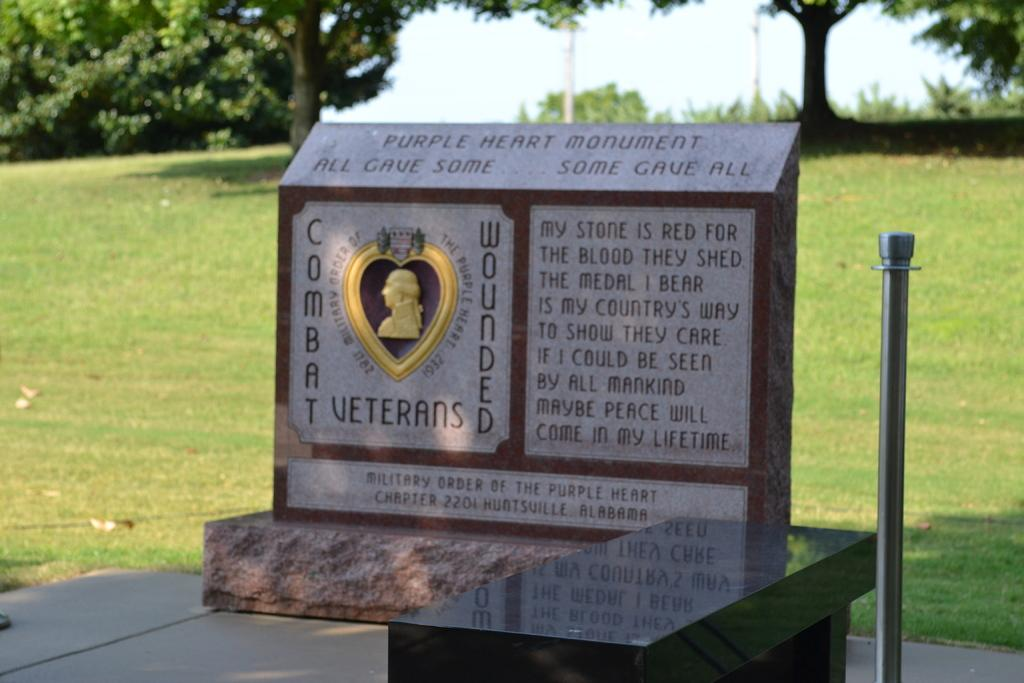What is the main subject of the image? There is a memorial in the image. What is located beside the memorial? There is a metal rod beside the memorial. What can be seen in the background of the image? There is grass, fence poles, and trees in the background of the image. Can you tell me how many monkeys are sitting on the memorial in the image? There are no monkeys present in the image; it features a memorial with a metal rod beside it. Who is the guide in the image? There is no guide present in the image. 